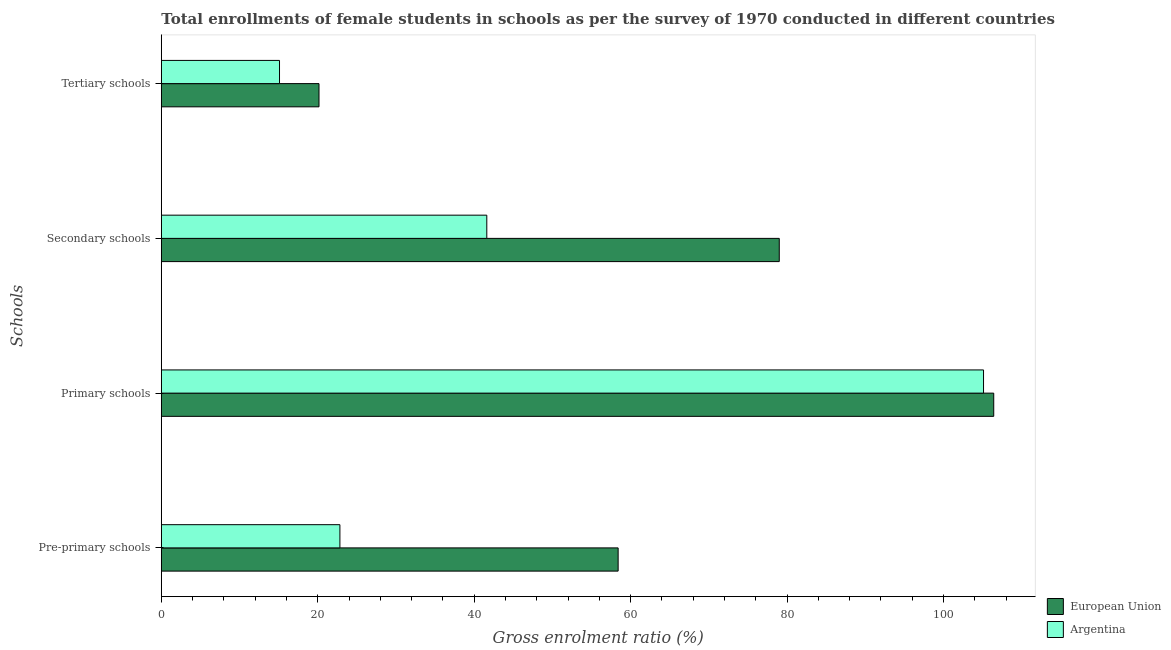How many groups of bars are there?
Ensure brevity in your answer.  4. Are the number of bars per tick equal to the number of legend labels?
Your response must be concise. Yes. Are the number of bars on each tick of the Y-axis equal?
Offer a very short reply. Yes. What is the label of the 1st group of bars from the top?
Provide a short and direct response. Tertiary schools. What is the gross enrolment ratio(female) in primary schools in Argentina?
Your answer should be compact. 105.12. Across all countries, what is the maximum gross enrolment ratio(female) in secondary schools?
Keep it short and to the point. 79.01. Across all countries, what is the minimum gross enrolment ratio(female) in tertiary schools?
Your answer should be compact. 15.11. In which country was the gross enrolment ratio(female) in pre-primary schools maximum?
Ensure brevity in your answer.  European Union. In which country was the gross enrolment ratio(female) in primary schools minimum?
Offer a very short reply. Argentina. What is the total gross enrolment ratio(female) in pre-primary schools in the graph?
Provide a short and direct response. 81.24. What is the difference between the gross enrolment ratio(female) in secondary schools in Argentina and that in European Union?
Offer a terse response. -37.39. What is the difference between the gross enrolment ratio(female) in pre-primary schools in European Union and the gross enrolment ratio(female) in primary schools in Argentina?
Offer a terse response. -46.71. What is the average gross enrolment ratio(female) in tertiary schools per country?
Make the answer very short. 17.64. What is the difference between the gross enrolment ratio(female) in secondary schools and gross enrolment ratio(female) in pre-primary schools in European Union?
Your response must be concise. 20.6. In how many countries, is the gross enrolment ratio(female) in pre-primary schools greater than 52 %?
Provide a succinct answer. 1. What is the ratio of the gross enrolment ratio(female) in secondary schools in European Union to that in Argentina?
Make the answer very short. 1.9. Is the difference between the gross enrolment ratio(female) in tertiary schools in Argentina and European Union greater than the difference between the gross enrolment ratio(female) in pre-primary schools in Argentina and European Union?
Your response must be concise. Yes. What is the difference between the highest and the second highest gross enrolment ratio(female) in pre-primary schools?
Make the answer very short. 35.57. What is the difference between the highest and the lowest gross enrolment ratio(female) in primary schools?
Ensure brevity in your answer.  1.3. Is it the case that in every country, the sum of the gross enrolment ratio(female) in secondary schools and gross enrolment ratio(female) in primary schools is greater than the sum of gross enrolment ratio(female) in tertiary schools and gross enrolment ratio(female) in pre-primary schools?
Your answer should be compact. Yes. What does the 2nd bar from the top in Pre-primary schools represents?
Make the answer very short. European Union. What does the 2nd bar from the bottom in Pre-primary schools represents?
Offer a terse response. Argentina. What is the difference between two consecutive major ticks on the X-axis?
Keep it short and to the point. 20. Are the values on the major ticks of X-axis written in scientific E-notation?
Your response must be concise. No. Does the graph contain grids?
Your response must be concise. No. How are the legend labels stacked?
Keep it short and to the point. Vertical. What is the title of the graph?
Your response must be concise. Total enrollments of female students in schools as per the survey of 1970 conducted in different countries. Does "Kazakhstan" appear as one of the legend labels in the graph?
Provide a succinct answer. No. What is the label or title of the Y-axis?
Your answer should be compact. Schools. What is the Gross enrolment ratio (%) of European Union in Pre-primary schools?
Provide a short and direct response. 58.41. What is the Gross enrolment ratio (%) in Argentina in Pre-primary schools?
Keep it short and to the point. 22.83. What is the Gross enrolment ratio (%) in European Union in Primary schools?
Make the answer very short. 106.42. What is the Gross enrolment ratio (%) in Argentina in Primary schools?
Offer a very short reply. 105.12. What is the Gross enrolment ratio (%) of European Union in Secondary schools?
Offer a terse response. 79.01. What is the Gross enrolment ratio (%) of Argentina in Secondary schools?
Provide a succinct answer. 41.61. What is the Gross enrolment ratio (%) of European Union in Tertiary schools?
Your response must be concise. 20.16. What is the Gross enrolment ratio (%) in Argentina in Tertiary schools?
Your response must be concise. 15.11. Across all Schools, what is the maximum Gross enrolment ratio (%) in European Union?
Give a very brief answer. 106.42. Across all Schools, what is the maximum Gross enrolment ratio (%) of Argentina?
Make the answer very short. 105.12. Across all Schools, what is the minimum Gross enrolment ratio (%) in European Union?
Offer a terse response. 20.16. Across all Schools, what is the minimum Gross enrolment ratio (%) in Argentina?
Offer a very short reply. 15.11. What is the total Gross enrolment ratio (%) of European Union in the graph?
Your answer should be compact. 264. What is the total Gross enrolment ratio (%) in Argentina in the graph?
Keep it short and to the point. 184.68. What is the difference between the Gross enrolment ratio (%) in European Union in Pre-primary schools and that in Primary schools?
Give a very brief answer. -48.02. What is the difference between the Gross enrolment ratio (%) of Argentina in Pre-primary schools and that in Primary schools?
Your answer should be compact. -82.29. What is the difference between the Gross enrolment ratio (%) in European Union in Pre-primary schools and that in Secondary schools?
Provide a succinct answer. -20.6. What is the difference between the Gross enrolment ratio (%) in Argentina in Pre-primary schools and that in Secondary schools?
Your answer should be compact. -18.78. What is the difference between the Gross enrolment ratio (%) of European Union in Pre-primary schools and that in Tertiary schools?
Offer a terse response. 38.24. What is the difference between the Gross enrolment ratio (%) in Argentina in Pre-primary schools and that in Tertiary schools?
Keep it short and to the point. 7.72. What is the difference between the Gross enrolment ratio (%) in European Union in Primary schools and that in Secondary schools?
Provide a short and direct response. 27.42. What is the difference between the Gross enrolment ratio (%) of Argentina in Primary schools and that in Secondary schools?
Offer a very short reply. 63.51. What is the difference between the Gross enrolment ratio (%) in European Union in Primary schools and that in Tertiary schools?
Keep it short and to the point. 86.26. What is the difference between the Gross enrolment ratio (%) of Argentina in Primary schools and that in Tertiary schools?
Make the answer very short. 90.01. What is the difference between the Gross enrolment ratio (%) in European Union in Secondary schools and that in Tertiary schools?
Your response must be concise. 58.85. What is the difference between the Gross enrolment ratio (%) of Argentina in Secondary schools and that in Tertiary schools?
Offer a terse response. 26.5. What is the difference between the Gross enrolment ratio (%) in European Union in Pre-primary schools and the Gross enrolment ratio (%) in Argentina in Primary schools?
Your answer should be very brief. -46.71. What is the difference between the Gross enrolment ratio (%) in European Union in Pre-primary schools and the Gross enrolment ratio (%) in Argentina in Secondary schools?
Provide a succinct answer. 16.79. What is the difference between the Gross enrolment ratio (%) in European Union in Pre-primary schools and the Gross enrolment ratio (%) in Argentina in Tertiary schools?
Your answer should be very brief. 43.29. What is the difference between the Gross enrolment ratio (%) of European Union in Primary schools and the Gross enrolment ratio (%) of Argentina in Secondary schools?
Give a very brief answer. 64.81. What is the difference between the Gross enrolment ratio (%) in European Union in Primary schools and the Gross enrolment ratio (%) in Argentina in Tertiary schools?
Your response must be concise. 91.31. What is the difference between the Gross enrolment ratio (%) of European Union in Secondary schools and the Gross enrolment ratio (%) of Argentina in Tertiary schools?
Provide a short and direct response. 63.89. What is the average Gross enrolment ratio (%) in European Union per Schools?
Provide a short and direct response. 66. What is the average Gross enrolment ratio (%) in Argentina per Schools?
Ensure brevity in your answer.  46.17. What is the difference between the Gross enrolment ratio (%) of European Union and Gross enrolment ratio (%) of Argentina in Pre-primary schools?
Your answer should be compact. 35.57. What is the difference between the Gross enrolment ratio (%) in European Union and Gross enrolment ratio (%) in Argentina in Primary schools?
Offer a terse response. 1.3. What is the difference between the Gross enrolment ratio (%) in European Union and Gross enrolment ratio (%) in Argentina in Secondary schools?
Offer a terse response. 37.39. What is the difference between the Gross enrolment ratio (%) in European Union and Gross enrolment ratio (%) in Argentina in Tertiary schools?
Ensure brevity in your answer.  5.05. What is the ratio of the Gross enrolment ratio (%) of European Union in Pre-primary schools to that in Primary schools?
Offer a very short reply. 0.55. What is the ratio of the Gross enrolment ratio (%) of Argentina in Pre-primary schools to that in Primary schools?
Make the answer very short. 0.22. What is the ratio of the Gross enrolment ratio (%) of European Union in Pre-primary schools to that in Secondary schools?
Provide a succinct answer. 0.74. What is the ratio of the Gross enrolment ratio (%) of Argentina in Pre-primary schools to that in Secondary schools?
Your answer should be compact. 0.55. What is the ratio of the Gross enrolment ratio (%) of European Union in Pre-primary schools to that in Tertiary schools?
Offer a very short reply. 2.9. What is the ratio of the Gross enrolment ratio (%) in Argentina in Pre-primary schools to that in Tertiary schools?
Your answer should be compact. 1.51. What is the ratio of the Gross enrolment ratio (%) in European Union in Primary schools to that in Secondary schools?
Give a very brief answer. 1.35. What is the ratio of the Gross enrolment ratio (%) in Argentina in Primary schools to that in Secondary schools?
Keep it short and to the point. 2.53. What is the ratio of the Gross enrolment ratio (%) in European Union in Primary schools to that in Tertiary schools?
Make the answer very short. 5.28. What is the ratio of the Gross enrolment ratio (%) of Argentina in Primary schools to that in Tertiary schools?
Offer a very short reply. 6.96. What is the ratio of the Gross enrolment ratio (%) of European Union in Secondary schools to that in Tertiary schools?
Provide a short and direct response. 3.92. What is the ratio of the Gross enrolment ratio (%) in Argentina in Secondary schools to that in Tertiary schools?
Offer a very short reply. 2.75. What is the difference between the highest and the second highest Gross enrolment ratio (%) of European Union?
Make the answer very short. 27.42. What is the difference between the highest and the second highest Gross enrolment ratio (%) in Argentina?
Provide a short and direct response. 63.51. What is the difference between the highest and the lowest Gross enrolment ratio (%) in European Union?
Provide a succinct answer. 86.26. What is the difference between the highest and the lowest Gross enrolment ratio (%) of Argentina?
Provide a short and direct response. 90.01. 